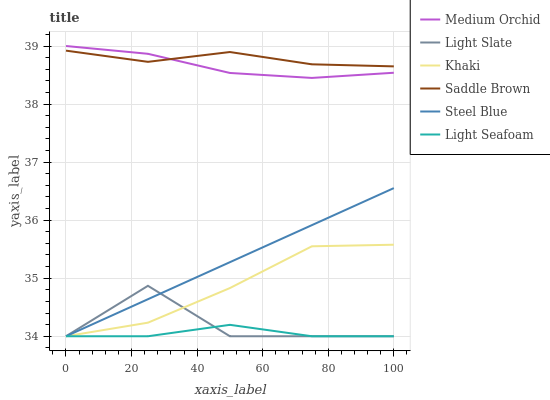Does Light Seafoam have the minimum area under the curve?
Answer yes or no. Yes. Does Saddle Brown have the maximum area under the curve?
Answer yes or no. Yes. Does Light Slate have the minimum area under the curve?
Answer yes or no. No. Does Light Slate have the maximum area under the curve?
Answer yes or no. No. Is Steel Blue the smoothest?
Answer yes or no. Yes. Is Light Slate the roughest?
Answer yes or no. Yes. Is Medium Orchid the smoothest?
Answer yes or no. No. Is Medium Orchid the roughest?
Answer yes or no. No. Does Medium Orchid have the lowest value?
Answer yes or no. No. Does Medium Orchid have the highest value?
Answer yes or no. Yes. Does Light Slate have the highest value?
Answer yes or no. No. Is Steel Blue less than Saddle Brown?
Answer yes or no. Yes. Is Medium Orchid greater than Light Seafoam?
Answer yes or no. Yes. Does Light Slate intersect Light Seafoam?
Answer yes or no. Yes. Is Light Slate less than Light Seafoam?
Answer yes or no. No. Is Light Slate greater than Light Seafoam?
Answer yes or no. No. Does Steel Blue intersect Saddle Brown?
Answer yes or no. No. 